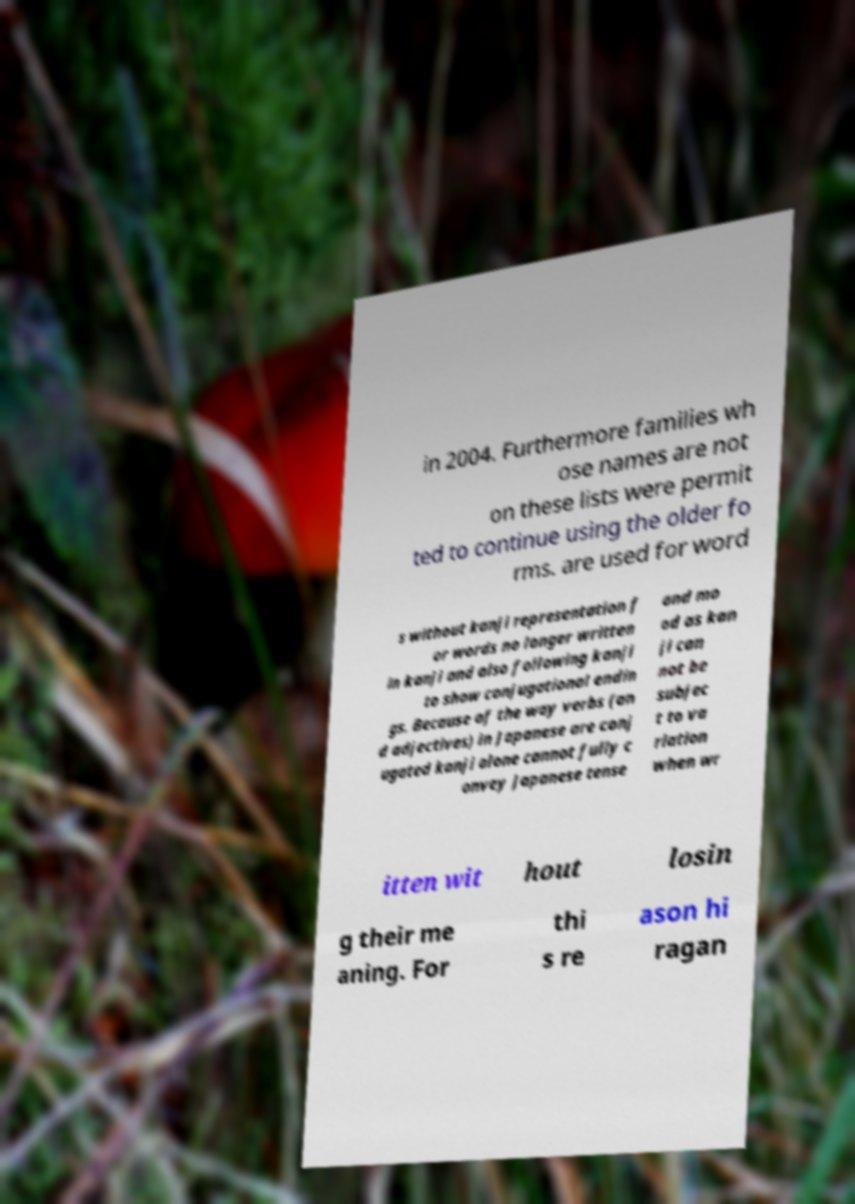For documentation purposes, I need the text within this image transcribed. Could you provide that? in 2004. Furthermore families wh ose names are not on these lists were permit ted to continue using the older fo rms. are used for word s without kanji representation f or words no longer written in kanji and also following kanji to show conjugational endin gs. Because of the way verbs (an d adjectives) in Japanese are conj ugated kanji alone cannot fully c onvey Japanese tense and mo od as kan ji can not be subjec t to va riation when wr itten wit hout losin g their me aning. For thi s re ason hi ragan 